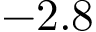Convert formula to latex. <formula><loc_0><loc_0><loc_500><loc_500>- 2 . 8</formula> 